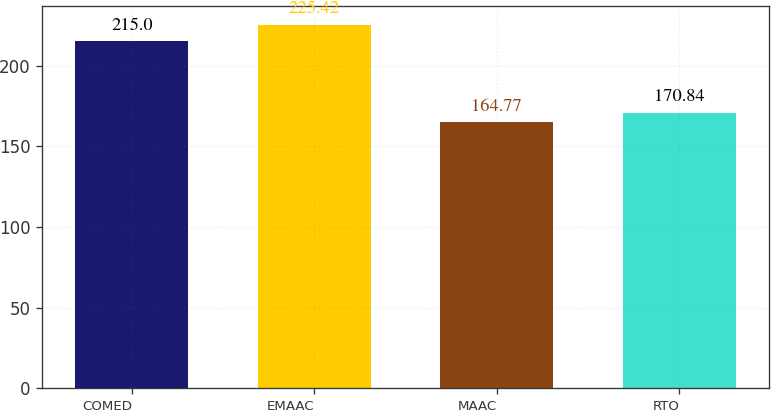<chart> <loc_0><loc_0><loc_500><loc_500><bar_chart><fcel>COMED<fcel>EMAAC<fcel>MAAC<fcel>RTO<nl><fcel>215<fcel>225.42<fcel>164.77<fcel>170.84<nl></chart> 